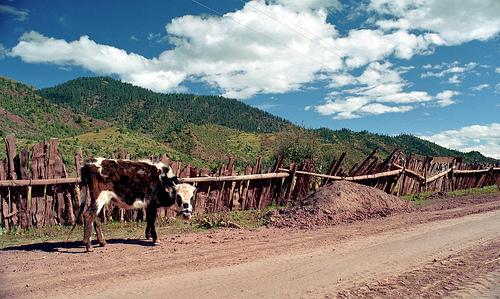Provide a brief analysis of the object interactions in the scene. The cow interacts with the dirt road, while a wooden fence and fence made of sticks provide some separation from the grass-covered mountains in the background. Identify the type of landscape in this scene and describe the sky. This is a countryside landscape with high mountains covered in green trees, and a blue sky with white and grey clouds. How many total brown wooden fence boards can you count in the image? There are 12 brown wooden fence boards in the image. Describe the condition of the fence present in the image and the material it is made of. The fence is a broken, leaning and uneven wooden fence along the road, made of brown wooden boards and sticks. How many main elements are in this picture and which one stands out the most. There are four main elements: the cow, the dirt road, the wooden fence, and the mountains. The cow stands out the most. What interaction can be seen between the main subject and the environment? The cow is standing on the side of a clay road, surrounded by a countryside setting, with a fence and mountains in the background. Can you explain what is apparent about the road in the image? There is a dirt road with a big bump on the side, as well as tracks and a dark shadow, surrounded by dirt ground and grass mountain. What type of animal is on the road, and what does the animal appear to be doing? The animal is a brown and white cow, which seems to be looking at the photographer. Comment on the quality of the image and its overall sentiment. The image is of good quality and emits a peaceful, rural sentiment. What is the main subject of the image, and can you describe how it looks? The main subject is a brown and white cow standing on a dirt road, with brown spots and a long brown tail. Describe the scene in this image. Scene in a countryside with a cow on the side of a clay road, leaning uneven fence along the road, high mountains covered with green trees, and blue sky with white and grey clouds. Considering the given information, what is the position of the white clouds in the blue sky? X:313, Y:44, Width:156, Height:156 What is the color and material of the fence in the image? Brown wooden fence Are there no clouds in the sky above the mountains? The captions mention white clouds in the blue sky, indicating that there are clouds present in the image. What part of the cow can be seen at the left-top corner and has a size of 26 by 26 pixels? The back legs of the cow List the colors of the sky and clouds in the image. Blue sky with white and grey clouds What body part of the cow has brown spots? The cow's coat From the given information, what can you conclude about the appearance of the fence in the image? The fence is made of wood and is leaning unevenly. Using the given information, deduce the size of the grass-covered mountain area of the scene. Width:492, Height:492 Are there any tracks in the dirt road? If so, specify their size. Yes, there are tracks in the dirt road with a width of 170 and a height of 170. What can you conclude about the appearance of the fence made of sticks? The fence is on the side and constructed from a series of elements of varying widths and heights. Is there any indication that the fence in the image is broken? Yes, there is a broken wooden fence. Does the cow have only white spots on its coat? The caption mentions the cow as having a white and brown coat, not just white spots. Identify the position of the cow's tail in relation to the image in terms of the X and Y coordinates. X:61, Y:165 What is covering the mountains in the image? Green trees Is the cow standing on the grass-covered mountains? The cow is actually on a dirt road, not on the grass-covered mountains. Are the mountains without green trees in the background? The captions mention high mountains covered with green trees, contradicting the instruction of mountains without any trees. Identify the type of road present in this image. Dirt road Is the fence made of metal instead of wood? The captions specifically mention the fence as being made of wood or sticks, not metal. Is the cow looking away from the photographer? One of the captions states that the cow is looking at the photographer, which contradicts the instruction that it's looking away. What activities can you infer from this image? (Choose one) B. Cow looking at the photographer Spot the pile of dirt on the ground in relation to the image. X:251, Y:174, Width:158, Height:158 Describe the ground on the grass mountain. Dirt ground What is the interaction between the cow and the photographer? The cow is looking at the photographer. 